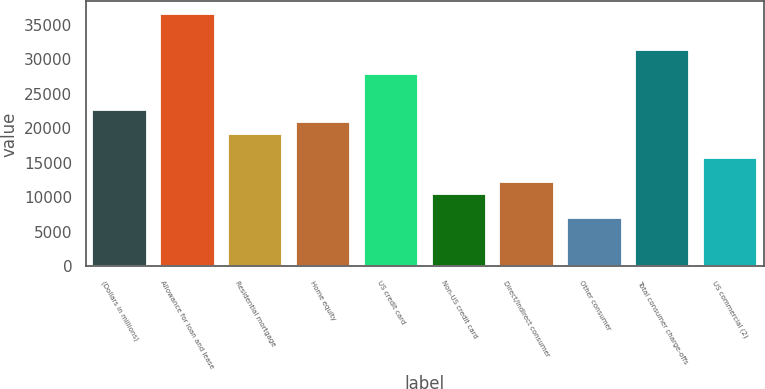Convert chart to OTSL. <chart><loc_0><loc_0><loc_500><loc_500><bar_chart><fcel>(Dollars in millions)<fcel>Allowance for loan and lease<fcel>Residential mortgage<fcel>Home equity<fcel>US credit card<fcel>Non-US credit card<fcel>Direct/Indirect consumer<fcel>Other consumer<fcel>Total consumer charge-offs<fcel>US commercial (2)<nl><fcel>22656.1<fcel>36597.7<fcel>19170.7<fcel>20913.4<fcel>27884.2<fcel>10457.2<fcel>12199.9<fcel>6971.8<fcel>31369.6<fcel>15685.3<nl></chart> 